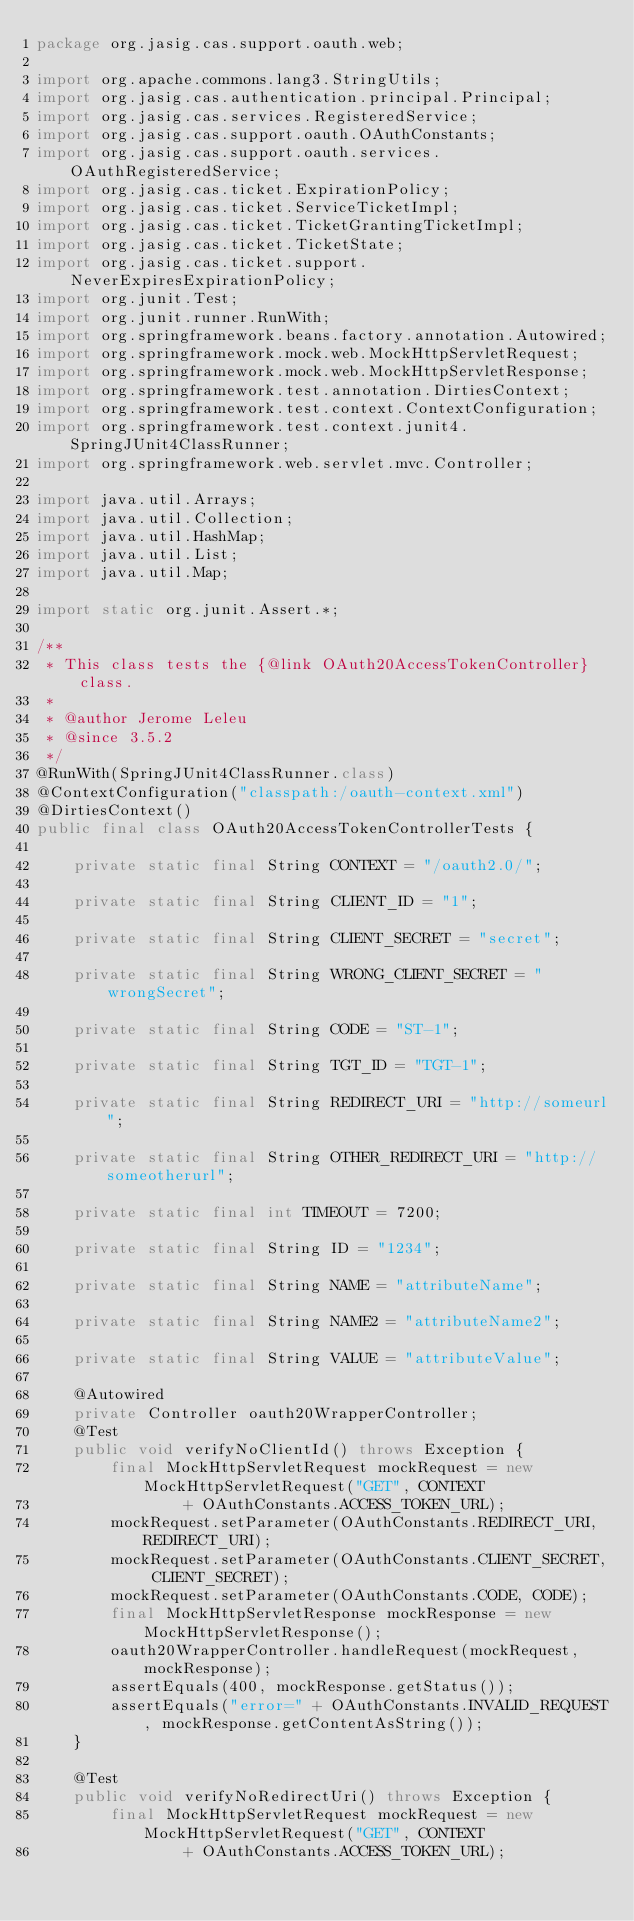Convert code to text. <code><loc_0><loc_0><loc_500><loc_500><_Java_>package org.jasig.cas.support.oauth.web;

import org.apache.commons.lang3.StringUtils;
import org.jasig.cas.authentication.principal.Principal;
import org.jasig.cas.services.RegisteredService;
import org.jasig.cas.support.oauth.OAuthConstants;
import org.jasig.cas.support.oauth.services.OAuthRegisteredService;
import org.jasig.cas.ticket.ExpirationPolicy;
import org.jasig.cas.ticket.ServiceTicketImpl;
import org.jasig.cas.ticket.TicketGrantingTicketImpl;
import org.jasig.cas.ticket.TicketState;
import org.jasig.cas.ticket.support.NeverExpiresExpirationPolicy;
import org.junit.Test;
import org.junit.runner.RunWith;
import org.springframework.beans.factory.annotation.Autowired;
import org.springframework.mock.web.MockHttpServletRequest;
import org.springframework.mock.web.MockHttpServletResponse;
import org.springframework.test.annotation.DirtiesContext;
import org.springframework.test.context.ContextConfiguration;
import org.springframework.test.context.junit4.SpringJUnit4ClassRunner;
import org.springframework.web.servlet.mvc.Controller;

import java.util.Arrays;
import java.util.Collection;
import java.util.HashMap;
import java.util.List;
import java.util.Map;

import static org.junit.Assert.*;

/**
 * This class tests the {@link OAuth20AccessTokenController} class.
 *
 * @author Jerome Leleu
 * @since 3.5.2
 */
@RunWith(SpringJUnit4ClassRunner.class)
@ContextConfiguration("classpath:/oauth-context.xml")
@DirtiesContext()
public final class OAuth20AccessTokenControllerTests {

    private static final String CONTEXT = "/oauth2.0/";

    private static final String CLIENT_ID = "1";

    private static final String CLIENT_SECRET = "secret";

    private static final String WRONG_CLIENT_SECRET = "wrongSecret";

    private static final String CODE = "ST-1";

    private static final String TGT_ID = "TGT-1";

    private static final String REDIRECT_URI = "http://someurl";

    private static final String OTHER_REDIRECT_URI = "http://someotherurl";

    private static final int TIMEOUT = 7200;

    private static final String ID = "1234";

    private static final String NAME = "attributeName";

    private static final String NAME2 = "attributeName2";

    private static final String VALUE = "attributeValue";

    @Autowired
    private Controller oauth20WrapperController;
    @Test
    public void verifyNoClientId() throws Exception {
        final MockHttpServletRequest mockRequest = new MockHttpServletRequest("GET", CONTEXT
                + OAuthConstants.ACCESS_TOKEN_URL);
        mockRequest.setParameter(OAuthConstants.REDIRECT_URI, REDIRECT_URI);
        mockRequest.setParameter(OAuthConstants.CLIENT_SECRET, CLIENT_SECRET);
        mockRequest.setParameter(OAuthConstants.CODE, CODE);
        final MockHttpServletResponse mockResponse = new MockHttpServletResponse();
        oauth20WrapperController.handleRequest(mockRequest, mockResponse);
        assertEquals(400, mockResponse.getStatus());
        assertEquals("error=" + OAuthConstants.INVALID_REQUEST, mockResponse.getContentAsString());
    }

    @Test
    public void verifyNoRedirectUri() throws Exception {
        final MockHttpServletRequest mockRequest = new MockHttpServletRequest("GET", CONTEXT
                + OAuthConstants.ACCESS_TOKEN_URL);</code> 